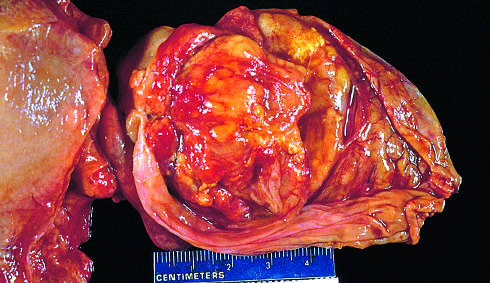does the opened gallbladder contain a large, exophytic tumor that virtually fills the lumen?
Answer the question using a single word or phrase. Yes 